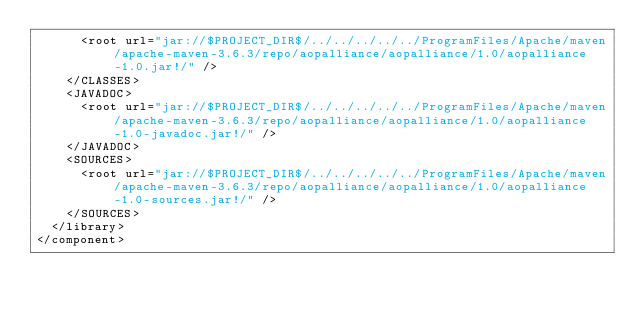<code> <loc_0><loc_0><loc_500><loc_500><_XML_>      <root url="jar://$PROJECT_DIR$/../../../../../ProgramFiles/Apache/maven/apache-maven-3.6.3/repo/aopalliance/aopalliance/1.0/aopalliance-1.0.jar!/" />
    </CLASSES>
    <JAVADOC>
      <root url="jar://$PROJECT_DIR$/../../../../../ProgramFiles/Apache/maven/apache-maven-3.6.3/repo/aopalliance/aopalliance/1.0/aopalliance-1.0-javadoc.jar!/" />
    </JAVADOC>
    <SOURCES>
      <root url="jar://$PROJECT_DIR$/../../../../../ProgramFiles/Apache/maven/apache-maven-3.6.3/repo/aopalliance/aopalliance/1.0/aopalliance-1.0-sources.jar!/" />
    </SOURCES>
  </library>
</component></code> 